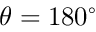<formula> <loc_0><loc_0><loc_500><loc_500>\theta = 1 8 0 ^ { \circ }</formula> 